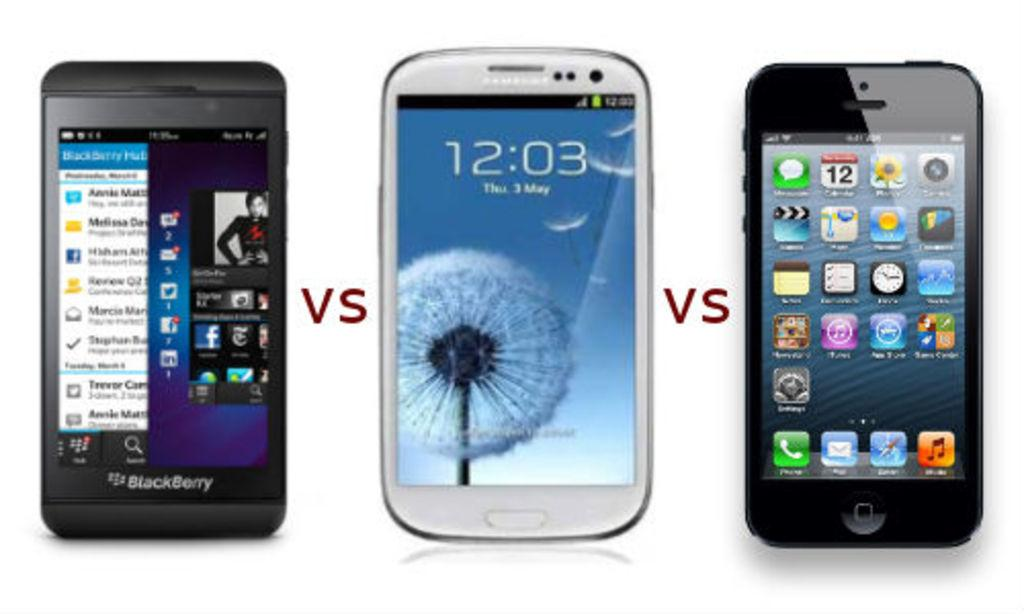<image>
Render a clear and concise summary of the photo. Three mobile phones are set to their home screens and the letters vs between them indicates a which is best scenario 